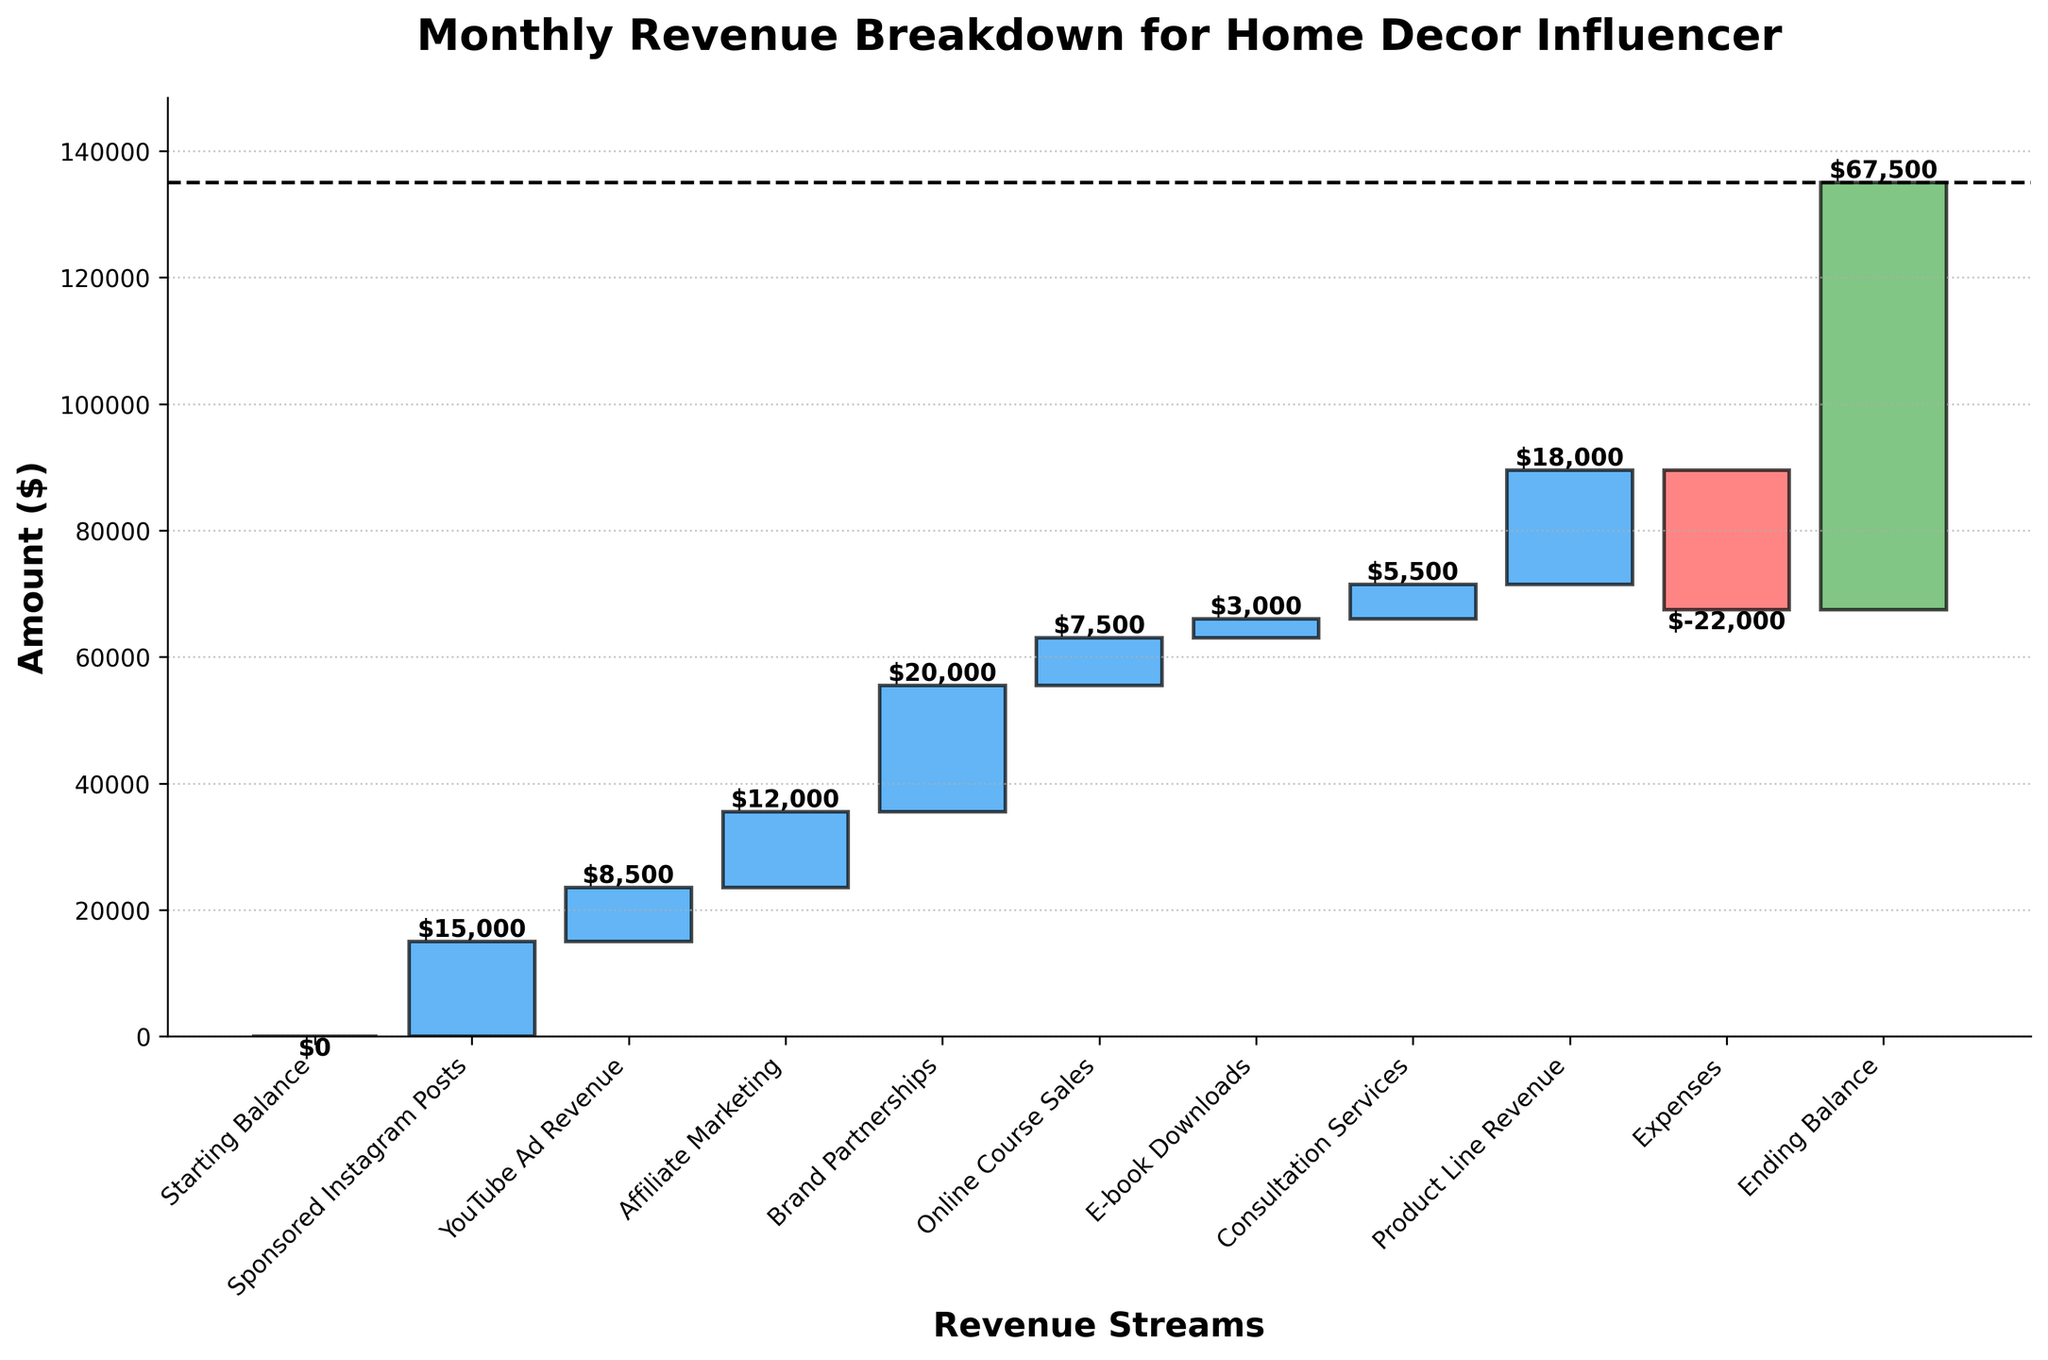What's the title of the chart? The title is positioned at the top of the chart, and it reads "Monthly Revenue Breakdown for Home Decor Influencer."
Answer: Monthly Revenue Breakdown for Home Decor Influencer What is the total revenue from Sponsored Instagram Posts? The chart shows individual amounts for each category, and for Sponsored Instagram Posts, it displays a value of $15,000.
Answer: $15,000 What are the expenses for the influencer in the given period? One of the bars is labeled "Expenses" and it shows a negative value of -$22,000.
Answer: $22,000 What is the ending balance for the month? The final bar in the chart is labeled "Ending Balance" and it shows a value of $67,500.
Answer: $67,500 Which revenue stream contributes the most to the total revenue? By comparing the heights of the positive bars, the highest value is found in the "Brand Partnerships" category, which is $20,000.
Answer: Brand Partnerships What is the difference between the revenue from Online Course Sales and Consultation Services? The revenue from Online Course Sales is $7,500 and from Consultation Services is $5,500. The difference is calculated as $7,500 - $5,500 = $2,000.
Answer: $2,000 How does the revenue from Product Line Revenue compare to Affiliate Marketing? The Product Line Revenue is $18,000, whereas the Affiliate Marketing revenue is $12,000. Product Line Revenue is higher by $18,000 - $12,000 = $6,000.
Answer: $6,000 What's the cumulative revenue after including YouTube Ad Revenue? The starting balance is 0. Adding the revenue from YouTube Ad Revenue of $8,500 results in a cumulative amount of $8,500.
Answer: $8,500 How much is the cumulative total after Brand Partnerships? Starting from 0, cumulative sum calculates by adding each category's values: $15,000 (Sponsored Instagram Posts) + $8,500 (YouTube Ad Revenue) + $12,000 (Affiliate Marketing) + $20,000 (Brand Partnerships) = $55,500.
Answer: $55,500 If the expenses were reduced by $5,000, what would be the new ending balance? The current expenses are $22,000. With a reduction of $5,000, the new expenses would be $17,000. The difference between the old and new expenses is $22,000 - $17,000 = $5,000. Adding this difference to the current ending balance: $67,500 + $5,000 = $72,500.
Answer: $72,500 